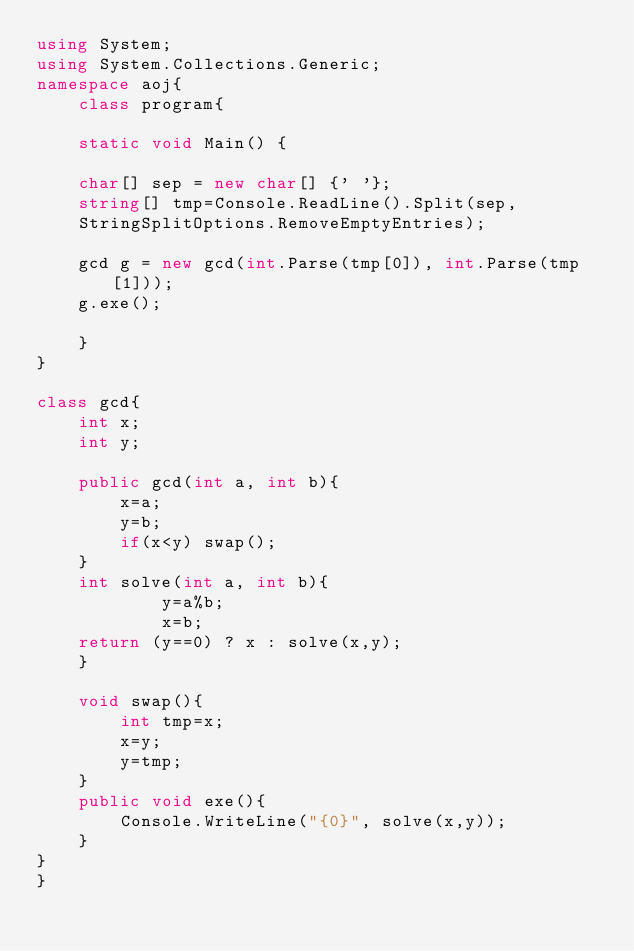<code> <loc_0><loc_0><loc_500><loc_500><_C#_>using System;
using System.Collections.Generic;
namespace aoj{
	class program{
	
	static void Main() {

	char[] sep = new char[] {' '};
	string[] tmp=Console.ReadLine().Split(sep,
	StringSplitOptions.RemoveEmptyEntries);

	gcd g = new gcd(int.Parse(tmp[0]), int.Parse(tmp[1]));
	g.exe();

	}
}

class gcd{
	int x;
	int y;
	
	public gcd(int a, int b){
		x=a;
		y=b;
		if(x<y) swap();
	}
	int solve(int a, int b){
			y=a%b;
			x=b;
	return (y==0) ? x : solve(x,y);
	}

	void swap(){
		int tmp=x;
		x=y;
		y=tmp;
	}
	public void exe(){
		Console.WriteLine("{0}", solve(x,y));
	}
}
}</code> 